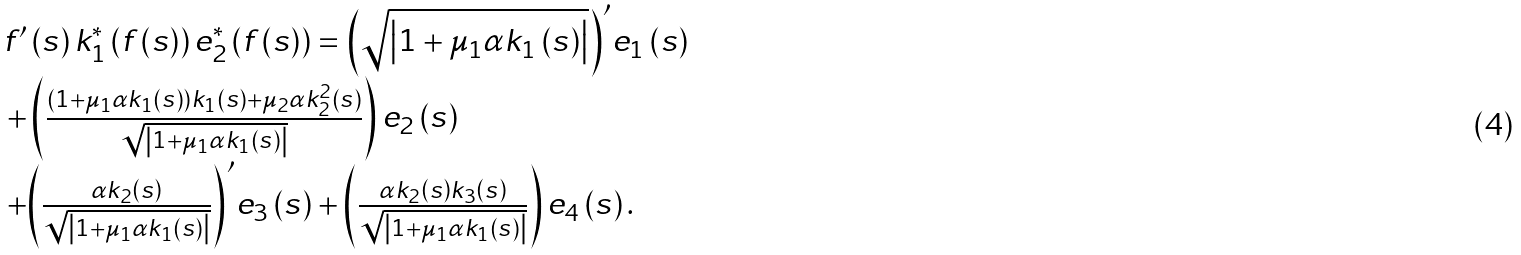Convert formula to latex. <formula><loc_0><loc_0><loc_500><loc_500>\begin{array} { l } f ^ { \prime } \left ( s \right ) k _ { 1 } ^ { * } \left ( { f \left ( s \right ) } \right ) { e } _ { 2 } ^ { * } \left ( { f \left ( s \right ) } \right ) = { \left ( { \sqrt { \left | { 1 + { \mu _ { 1 } } \alpha { k _ { 1 } } \left ( s \right ) } \right | } } \right ) ^ { \prime } } { { e } _ { 1 } } \left ( s \right ) \\ \, + \left ( { \frac { { \left ( { 1 + { \mu _ { 1 } } \alpha { k _ { 1 } } \left ( s \right ) } \right ) { k _ { 1 } } \left ( s \right ) + { \mu _ { 2 } } \alpha k _ { 2 } ^ { 2 } \left ( s \right ) } } { { \sqrt { \left | { 1 + { \mu _ { 1 } } \alpha { k _ { 1 } } \left ( s \right ) } \right | } } } } \right ) { { e } _ { 2 } } \left ( s \right ) \\ \, + { \left ( { \frac { { \alpha { k _ { 2 } } \left ( s \right ) } } { { \sqrt { \left | { 1 + { \mu _ { 1 } } \alpha { k _ { 1 } } \left ( s \right ) } \right | } } } } \right ) ^ { \prime } } { { e } _ { 3 } } \left ( s \right ) + \left ( { \frac { { \alpha { k _ { 2 } } \left ( s \right ) { k _ { 3 } } \left ( s \right ) } } { { \sqrt { \left | { 1 + { \mu _ { 1 } } \alpha { k _ { 1 } } \left ( s \right ) } \right | } } } } \right ) { { e } _ { 4 } } \left ( s \right ) . \\ \end{array}</formula> 